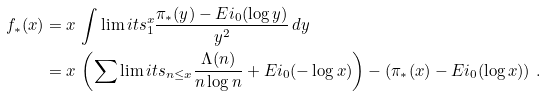<formula> <loc_0><loc_0><loc_500><loc_500>f _ { * } ( x ) & = x \, \int \lim i t s _ { 1 } ^ { x } \frac { \pi _ { * } ( y ) - E i _ { 0 } ( \log y ) } { y ^ { 2 } } \, d y \\ & = x \, \left ( \sum \lim i t s _ { n \leq x } \frac { \Lambda ( n ) } { n \log n } + E i _ { 0 } ( - \log x ) \right ) - \left ( \pi _ { * } ( x ) - E i _ { 0 } ( \log x ) \right ) \, .</formula> 